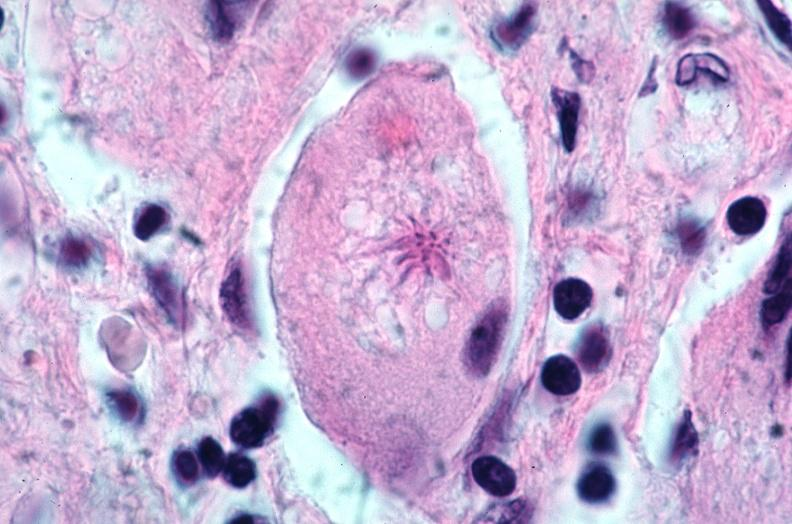does this image show lung, sarcoidosis, multinucleated giant cells with asteroid bodies?
Answer the question using a single word or phrase. Yes 